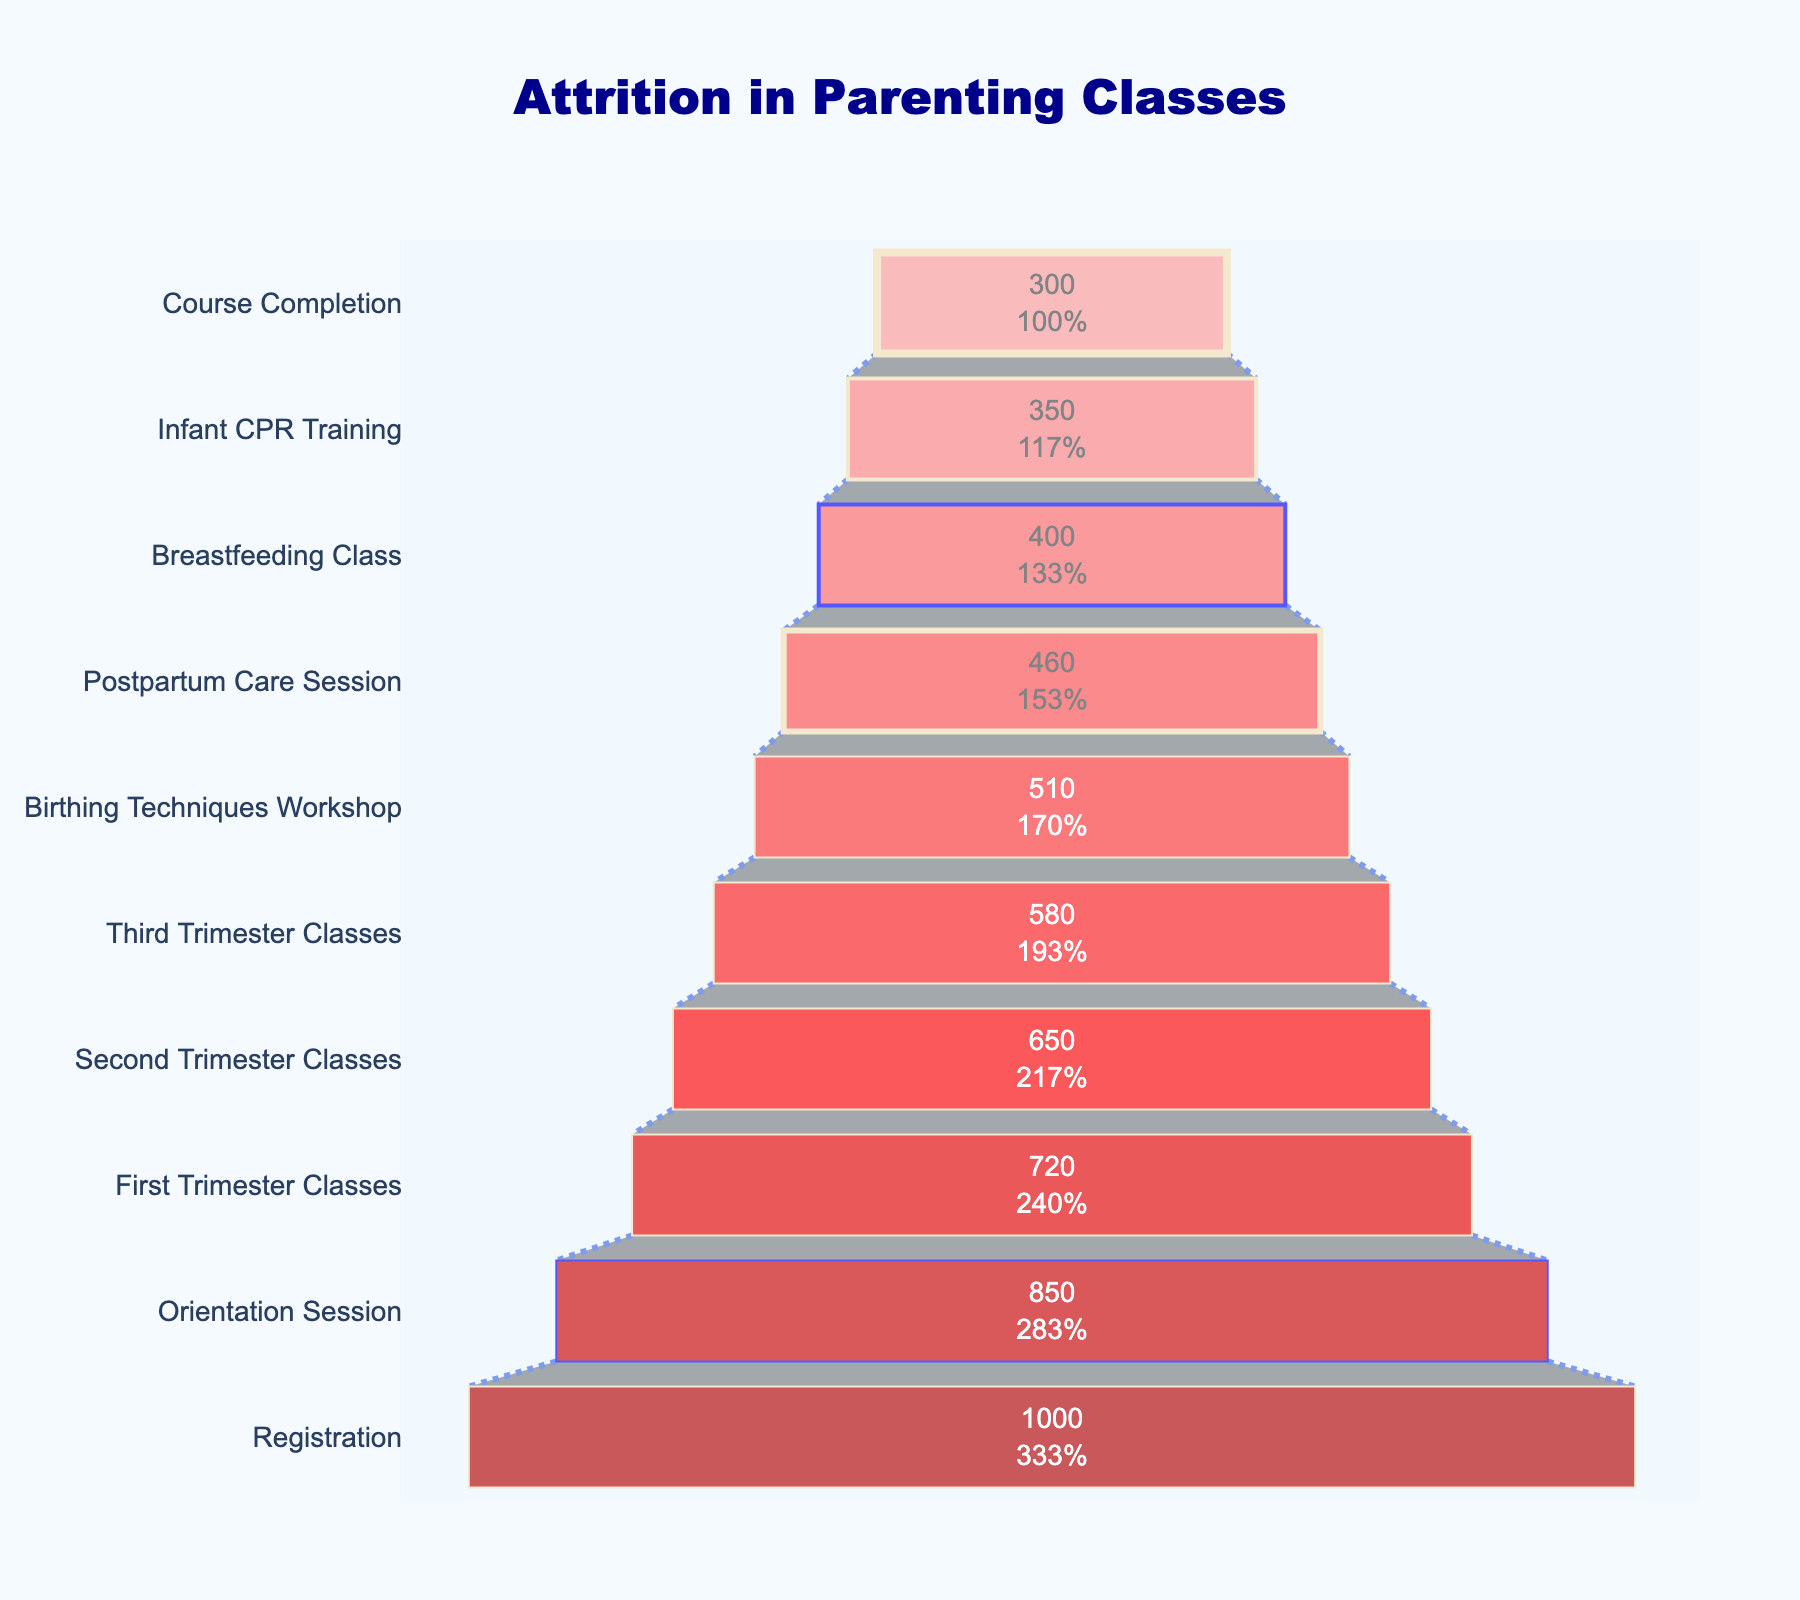What's the title of the funnel chart? The title is displayed at the top center of the chart, prominently. It reads "Attrition in Parenting Classes".
Answer: Attrition in Parenting Classes How many participants completed the Course Completion stage? The bottom stage of the funnel chart represents the Course Completion stage, indicating the number of participants.
Answer: 300 What is the percentage drop from the Orientation Session to the Birthing Techniques Workshop? First, note participants in the Orientation Session (850) and Birthing Techniques Workshop (510). Calculate the drop percentage as ((850 - 510) / 850) * 100 = ~40%.
Answer: ~40% Which stage has the second-highest number of participants? The funnel chart lists stages from the most participants (top) to the least (bottom). The second stage from the top, Orientation Session, has 850 participants.
Answer: Orientation Session How many participants attended both the Third Trimester Classes and the Breastfeeding Class? Participants in Third Trimester Classes are 580, and those in the Breastfeeding Class are 400. Subtract participants in Breastfeeding Class from those in Third Trimester Classes: 580 - 400 = 180.
Answer: 180 What's the total number of participants that dropped out before the course completion? Initial participants were 1000, and 300 completed the course. Thus, those who dropped out are 1000 - 300 = 700.
Answer: 700 Between which two consecutive stages is the largest drop in the number of participants? Compare the drop between each consecutive pair of stages. The largest drop is between Registration (1000) and Orientation Session (850) with a difference of 150 participants.
Answer: Registration to Orientation Session What percentage of registered participants completed the First Trimester Classes? Registered participants were 1000, and those who completed First Trimester Classes were 720. Calculate the completion percentage as (720 / 1000) * 100 = 72%.
Answer: 72% What stage follows the Second Trimester Classes? The Second Trimester Classes stage lists 650 participants, and the next stage downwards (fewer participants) is Third Trimester Classes.
Answer: Third Trimester Classes What's the difference in participant numbers between the Birthing Techniques Workshop and Infant CPR Training? Birthing Techniques Workshop has 510 participants and Infant CPR Training has 350 participants. The difference is 510 - 350 = 160.
Answer: 160 